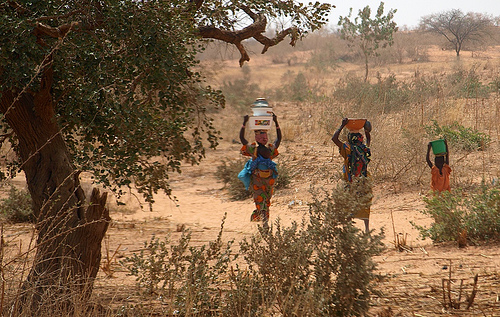<image>
Is there a woman behind the bowl? No. The woman is not behind the bowl. From this viewpoint, the woman appears to be positioned elsewhere in the scene. Is the person on the water? No. The person is not positioned on the water. They may be near each other, but the person is not supported by or resting on top of the water. 